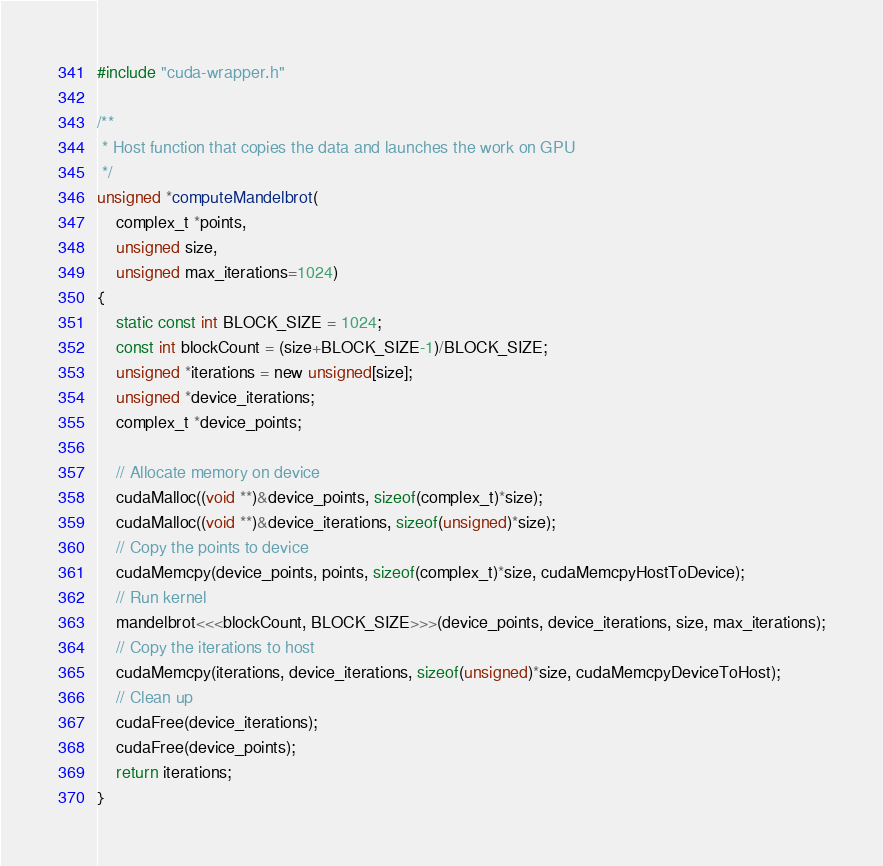<code> <loc_0><loc_0><loc_500><loc_500><_Cuda_>#include "cuda-wrapper.h"

/**
 * Host function that copies the data and launches the work on GPU
 */
unsigned *computeMandelbrot(
	complex_t *points,
	unsigned size,
	unsigned max_iterations=1024)
{
	static const int BLOCK_SIZE = 1024;
	const int blockCount = (size+BLOCK_SIZE-1)/BLOCK_SIZE;
	unsigned *iterations = new unsigned[size];
	unsigned *device_iterations;
	complex_t *device_points;

	// Allocate memory on device
	cudaMalloc((void **)&device_points, sizeof(complex_t)*size);
	cudaMalloc((void **)&device_iterations, sizeof(unsigned)*size);
	// Copy the points to device
	cudaMemcpy(device_points, points, sizeof(complex_t)*size, cudaMemcpyHostToDevice);
	// Run kernel
	mandelbrot<<<blockCount, BLOCK_SIZE>>>(device_points, device_iterations, size, max_iterations);
	// Copy the iterations to host
	cudaMemcpy(iterations, device_iterations, sizeof(unsigned)*size, cudaMemcpyDeviceToHost);
	// Clean up 
	cudaFree(device_iterations);
	cudaFree(device_points);
	return iterations;
}
</code> 